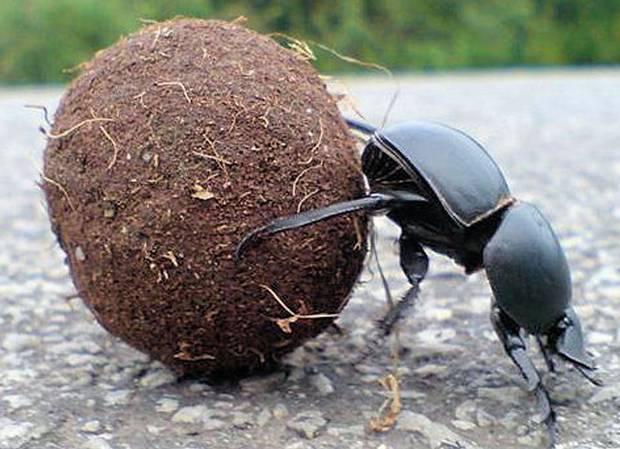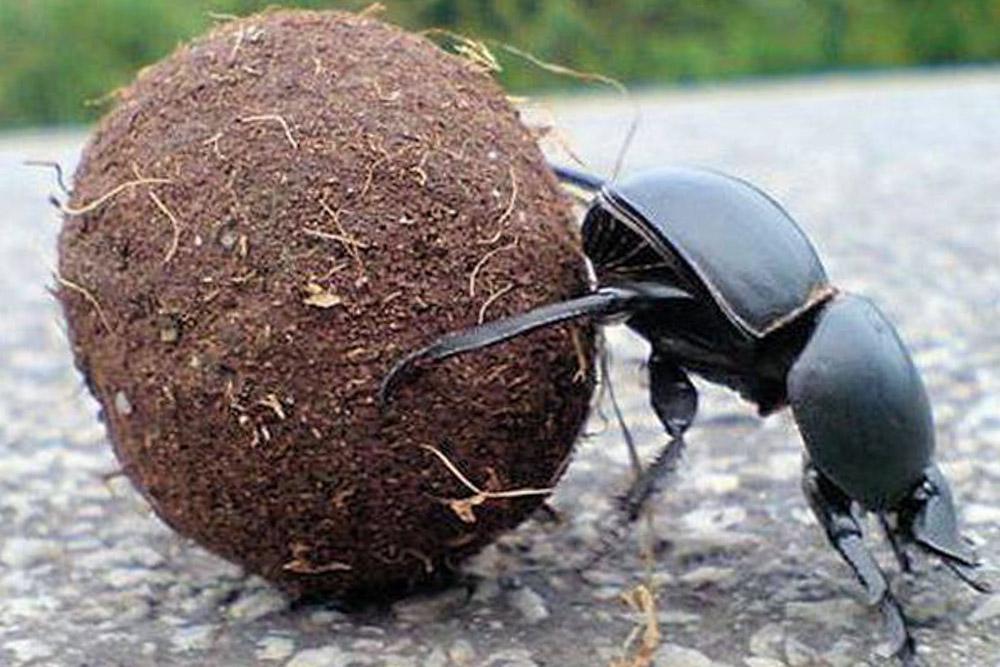The first image is the image on the left, the second image is the image on the right. For the images shown, is this caption "The image on the left shows two beetles on top of a dungball." true? Answer yes or no. No. 